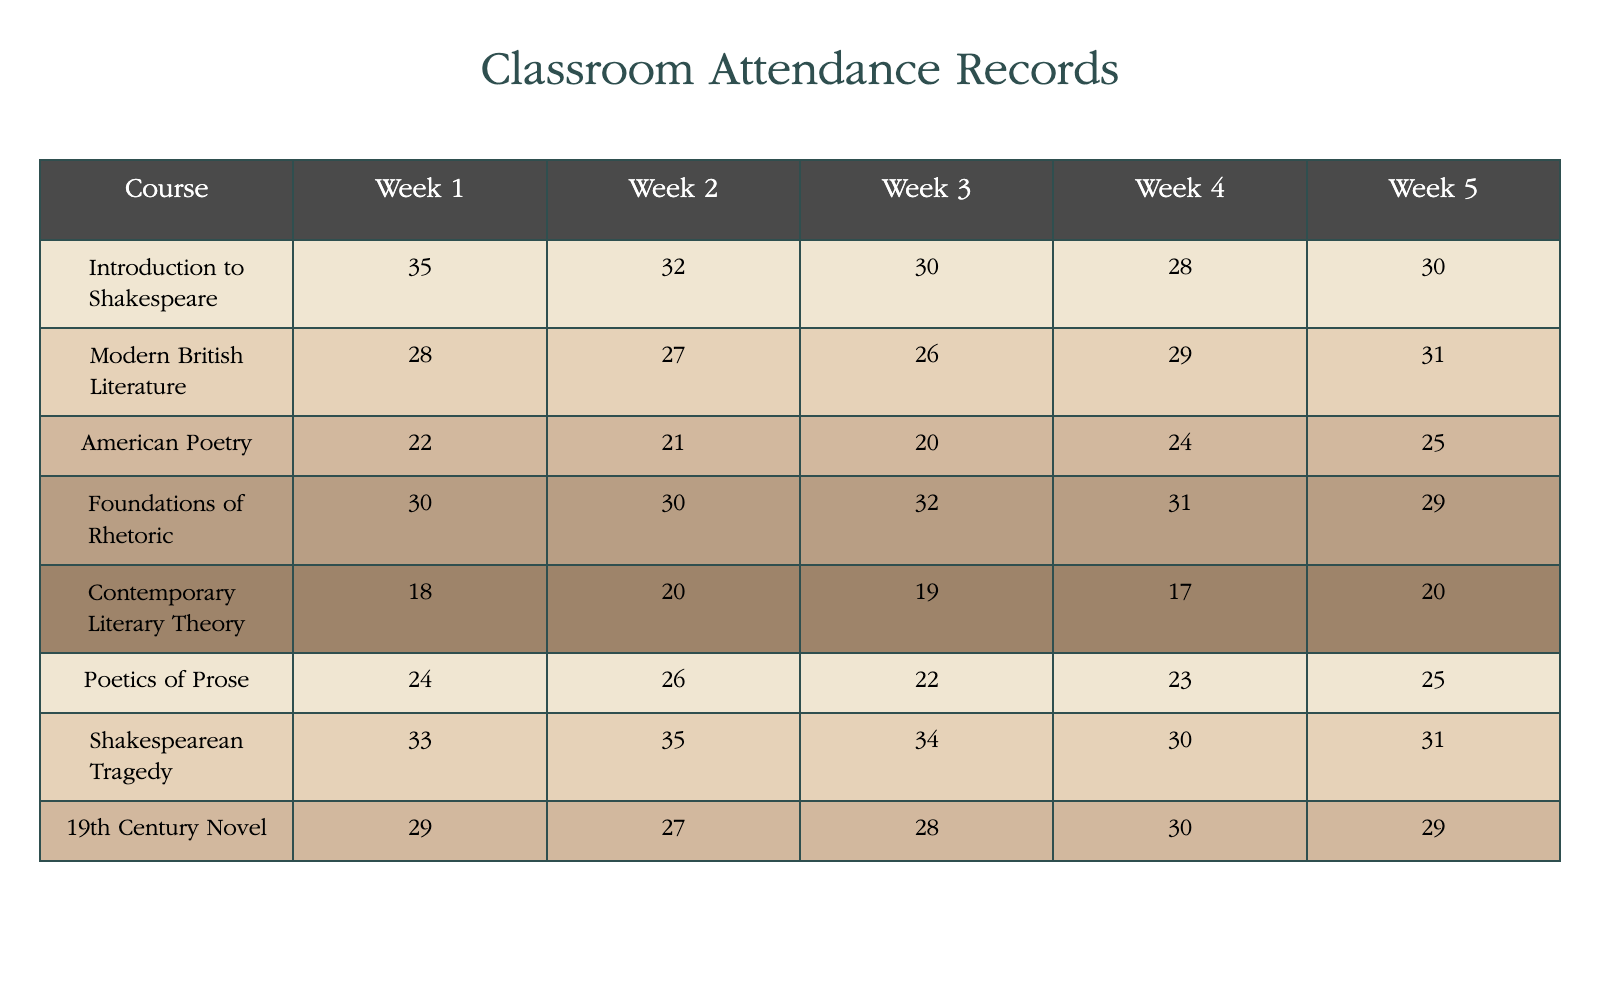What is the attendance for "Shakespearean Tragedy" in Week 3? The attendance for "Shakespearean Tragedy" is listed directly in the table under Week 3. It shows a value of 34.
Answer: 34 What was the highest attendance recorded in Week 5? By looking at the table, the highest attendance in Week 5 is found by comparing the values for each course. The maximum value is 31 from "Modern British Literature."
Answer: 31 What is the average attendance across all courses in Week 2? To find the average for Week 2, add the attendance values for each course: (32 + 27 + 21 + 30 + 20 + 26 + 35 + 27) = 288. There are 8 courses, so the average is 288 / 8 = 36.
Answer: 36 Did "Contemporary Literary Theory" have a higher attendance in Week 1 than "American Poetry"? Comparing the values in Week 1, "Contemporary Literary Theory" shows an attendance of 18, while "American Poetry" has 22. Since 18 is less than 22, the statement is false.
Answer: No Which course showed the largest decrease in attendance from Week 1 to Week 4? To identify the largest decrease, subtract the Week 4 attendance from the Week 1 attendance for each course. The largest decrease is found with "Introduction to Shakespeare," where the drop is 35 - 28 = 7.
Answer: "Introduction to Shakespeare" What was the total attendance for "Foundations of Rhetoric" over the five weeks? To find the total, add the attendance for all weeks for "Foundations of Rhetoric": 30 + 30 + 32 + 31 + 29 = 152.
Answer: 152 How many total students attended "Modern British Literature" over the five weeks? The total attendance for "Modern British Literature" is found by summing the attendance across all weeks: 28 + 27 + 26 + 29 + 31 = 141.
Answer: 141 Was the attendance for "Poetics of Prose" less than the average of all courses in Week 3? The attendance for "Poetics of Prose" in Week 3 is 22. First, calculate the average for Week 3 by summing: (30 + 26 + 20 + 32 + 19 + 22 + 34 + 28) =  221, and dividing by 8 gives us an average of 27.625. Since 22 < 27.625, the answer is yes.
Answer: Yes 